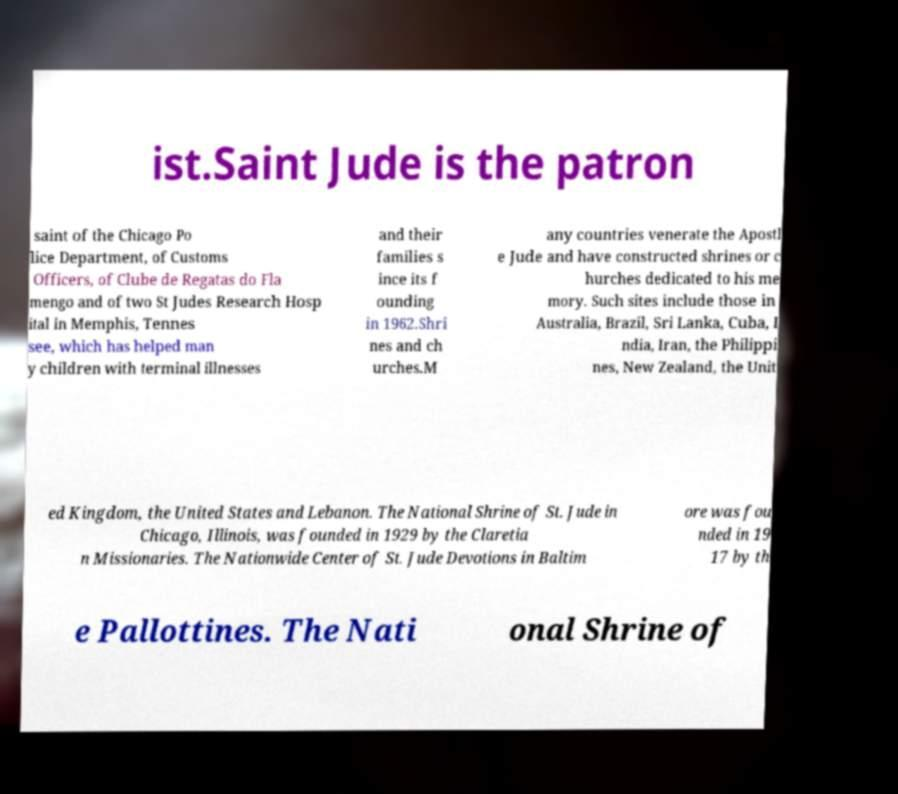Please identify and transcribe the text found in this image. ist.Saint Jude is the patron saint of the Chicago Po lice Department, of Customs Officers, of Clube de Regatas do Fla mengo and of two St Judes Research Hosp ital in Memphis, Tennes see, which has helped man y children with terminal illnesses and their families s ince its f ounding in 1962.Shri nes and ch urches.M any countries venerate the Apostl e Jude and have constructed shrines or c hurches dedicated to his me mory. Such sites include those in Australia, Brazil, Sri Lanka, Cuba, I ndia, Iran, the Philippi nes, New Zealand, the Unit ed Kingdom, the United States and Lebanon. The National Shrine of St. Jude in Chicago, Illinois, was founded in 1929 by the Claretia n Missionaries. The Nationwide Center of St. Jude Devotions in Baltim ore was fou nded in 19 17 by th e Pallottines. The Nati onal Shrine of 